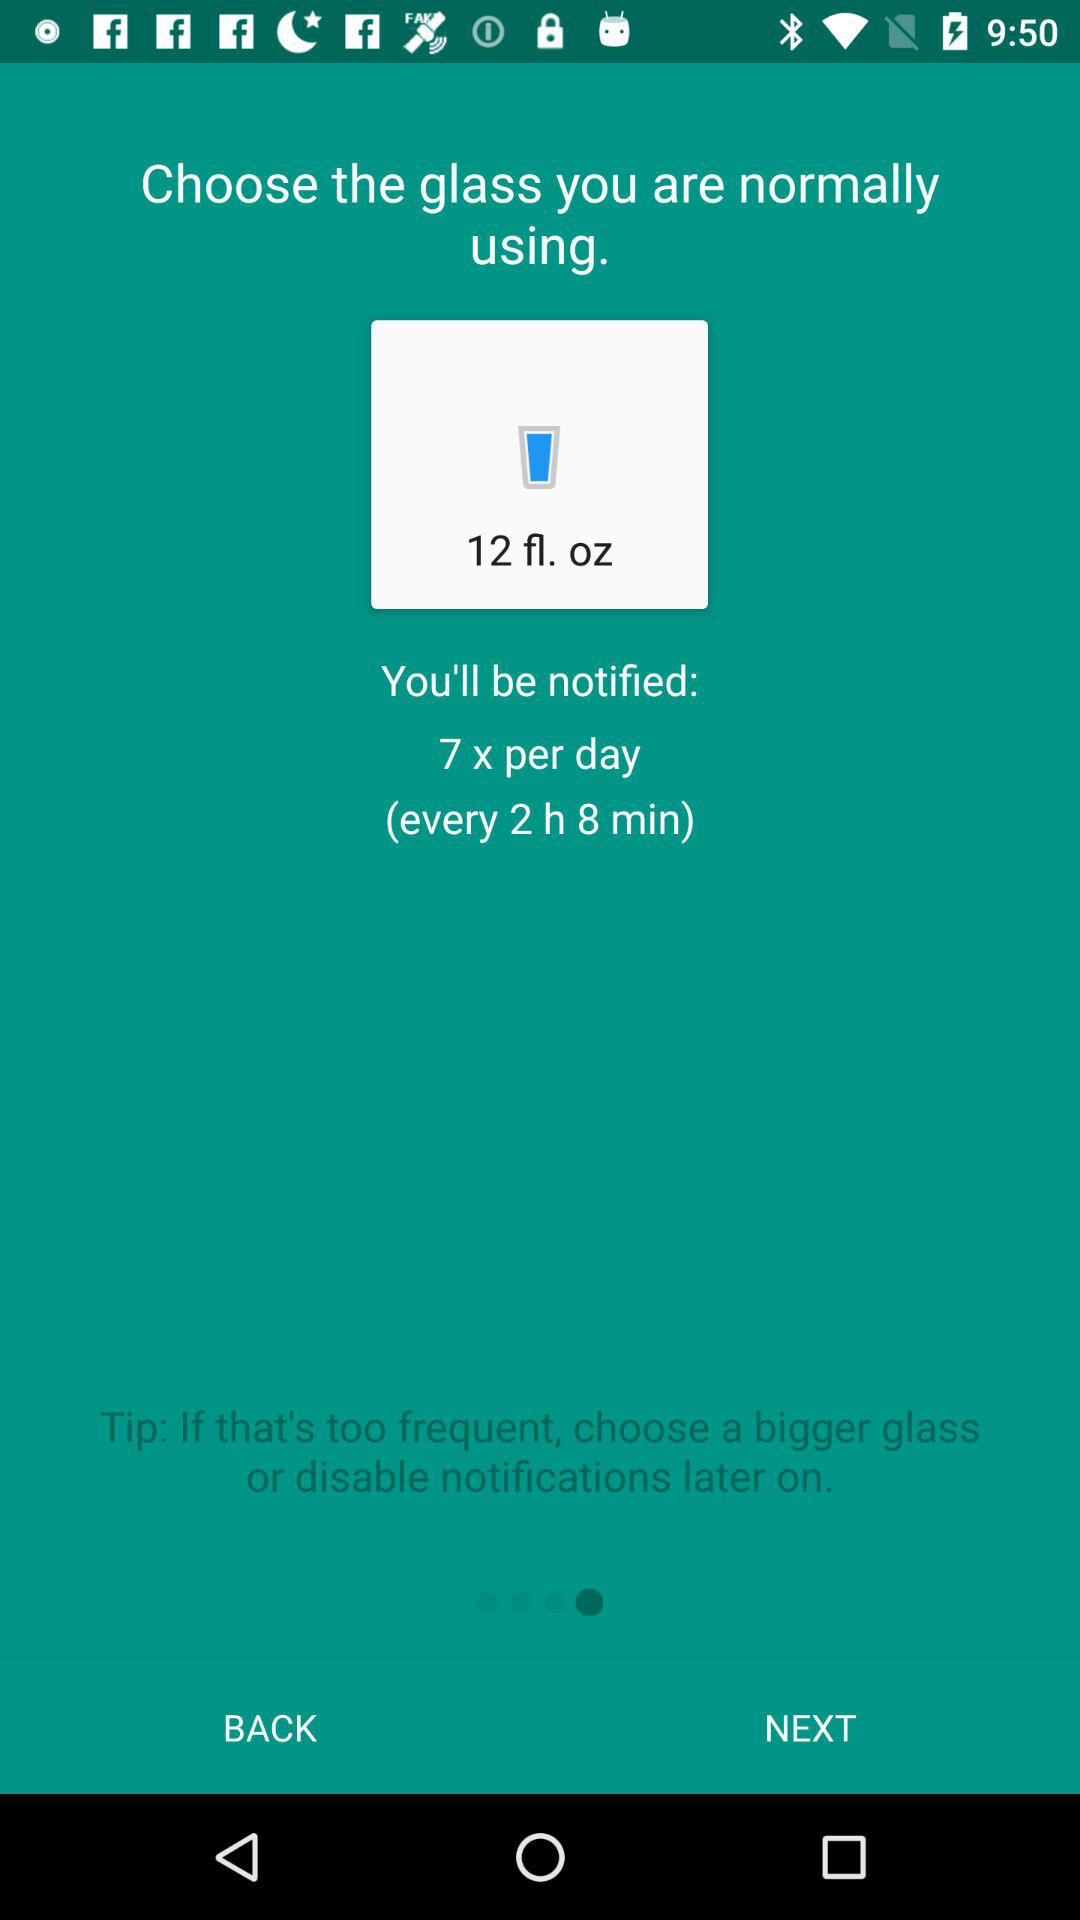How many more ounces of water will I drink if I choose a 16 oz glass?
Answer the question using a single word or phrase. 4 